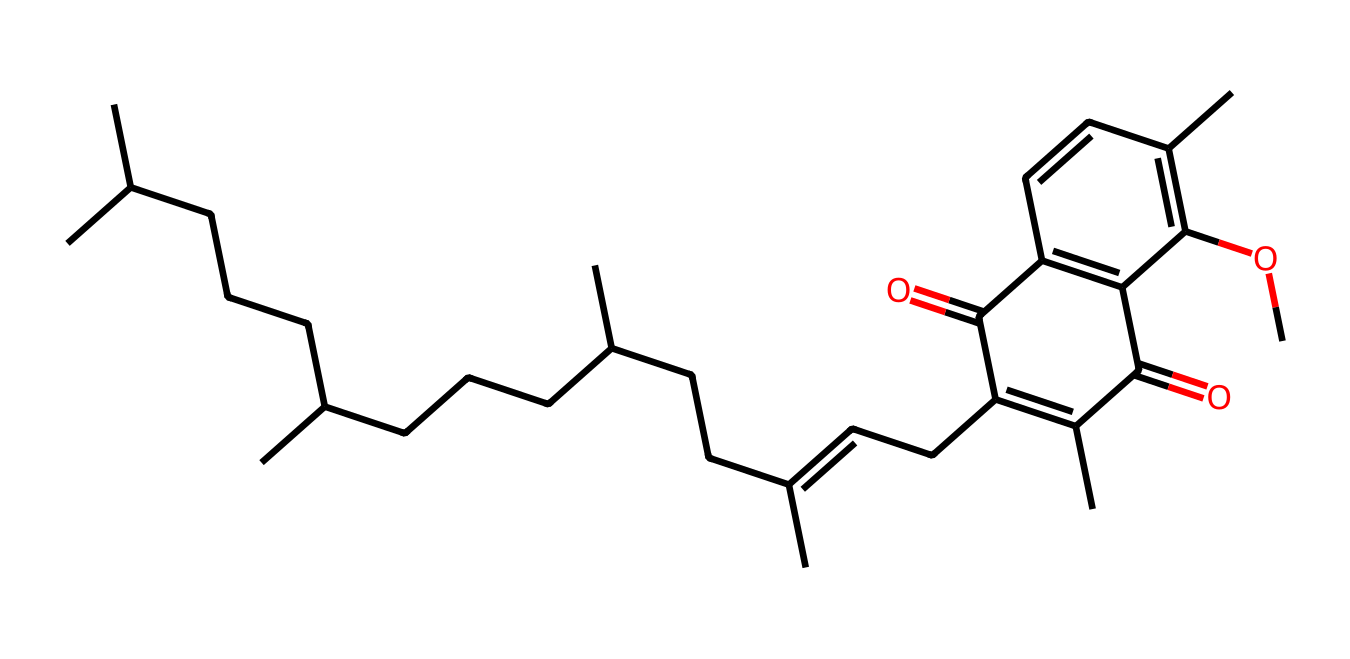What is the molecular formula of vitamin K2 (menaquinone)? To determine the molecular formula, count the number of each type of atom present in the SMILES representation. The atoms include multiple carbon (C) atoms, hydrogen (H) atoms, and oxygen (O) atoms. Upon analysis, the molecular formula is C31H46O2.
Answer: C31H46O2 How many double bonds are present in the molecular structure? By examining the SMILES representation, identify areas that contain a double bond (indicated by '=' signs). Analysis shows that there are a total of 6 double bonds in the structure.
Answer: 6 Which functional groups are present in vitamin K2? Reviewing the SMILES reveals the presence of a carbonyl group (C=O) and an ether group (C-O-C) in the chemical structure. This helps classify the molecule and determine its reactivity.
Answer: carbonyl and ether What is the length of the longest carbon chain in vitamin K2? To find the longest carbon chain, trace the backbone of carbon atoms while ensuring you follow the rules for chain length without skipping. Counting the carbon atoms in the longest continuous chain shows that it has 16 carbon atoms.
Answer: 16 What makes vitamin K2 essential for biological functions? Vitamin K2 is critical for the synthesis of specific proteins that regulate bone metabolism and blood coagulation. The unique structure and functional groups contribute to its biological activity and interaction with proteins.
Answer: synthesis of proteins Can the structure of vitamin K2 be utilized in quantum computing materials? The unique molecular structure and electron configurations of vitamin K2 can potentially serve as qubits or in spintronic applications because of their distinct electronic properties. This offers insights into further research possibilities in quantum materials.
Answer: potential for qubits 